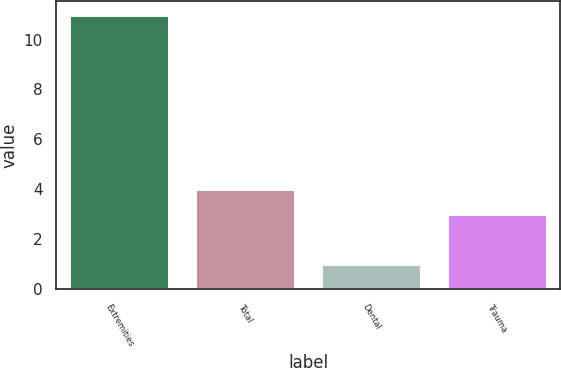Convert chart. <chart><loc_0><loc_0><loc_500><loc_500><bar_chart><fcel>Extremities<fcel>Total<fcel>Dental<fcel>Trauma<nl><fcel>11<fcel>4<fcel>1<fcel>3<nl></chart> 